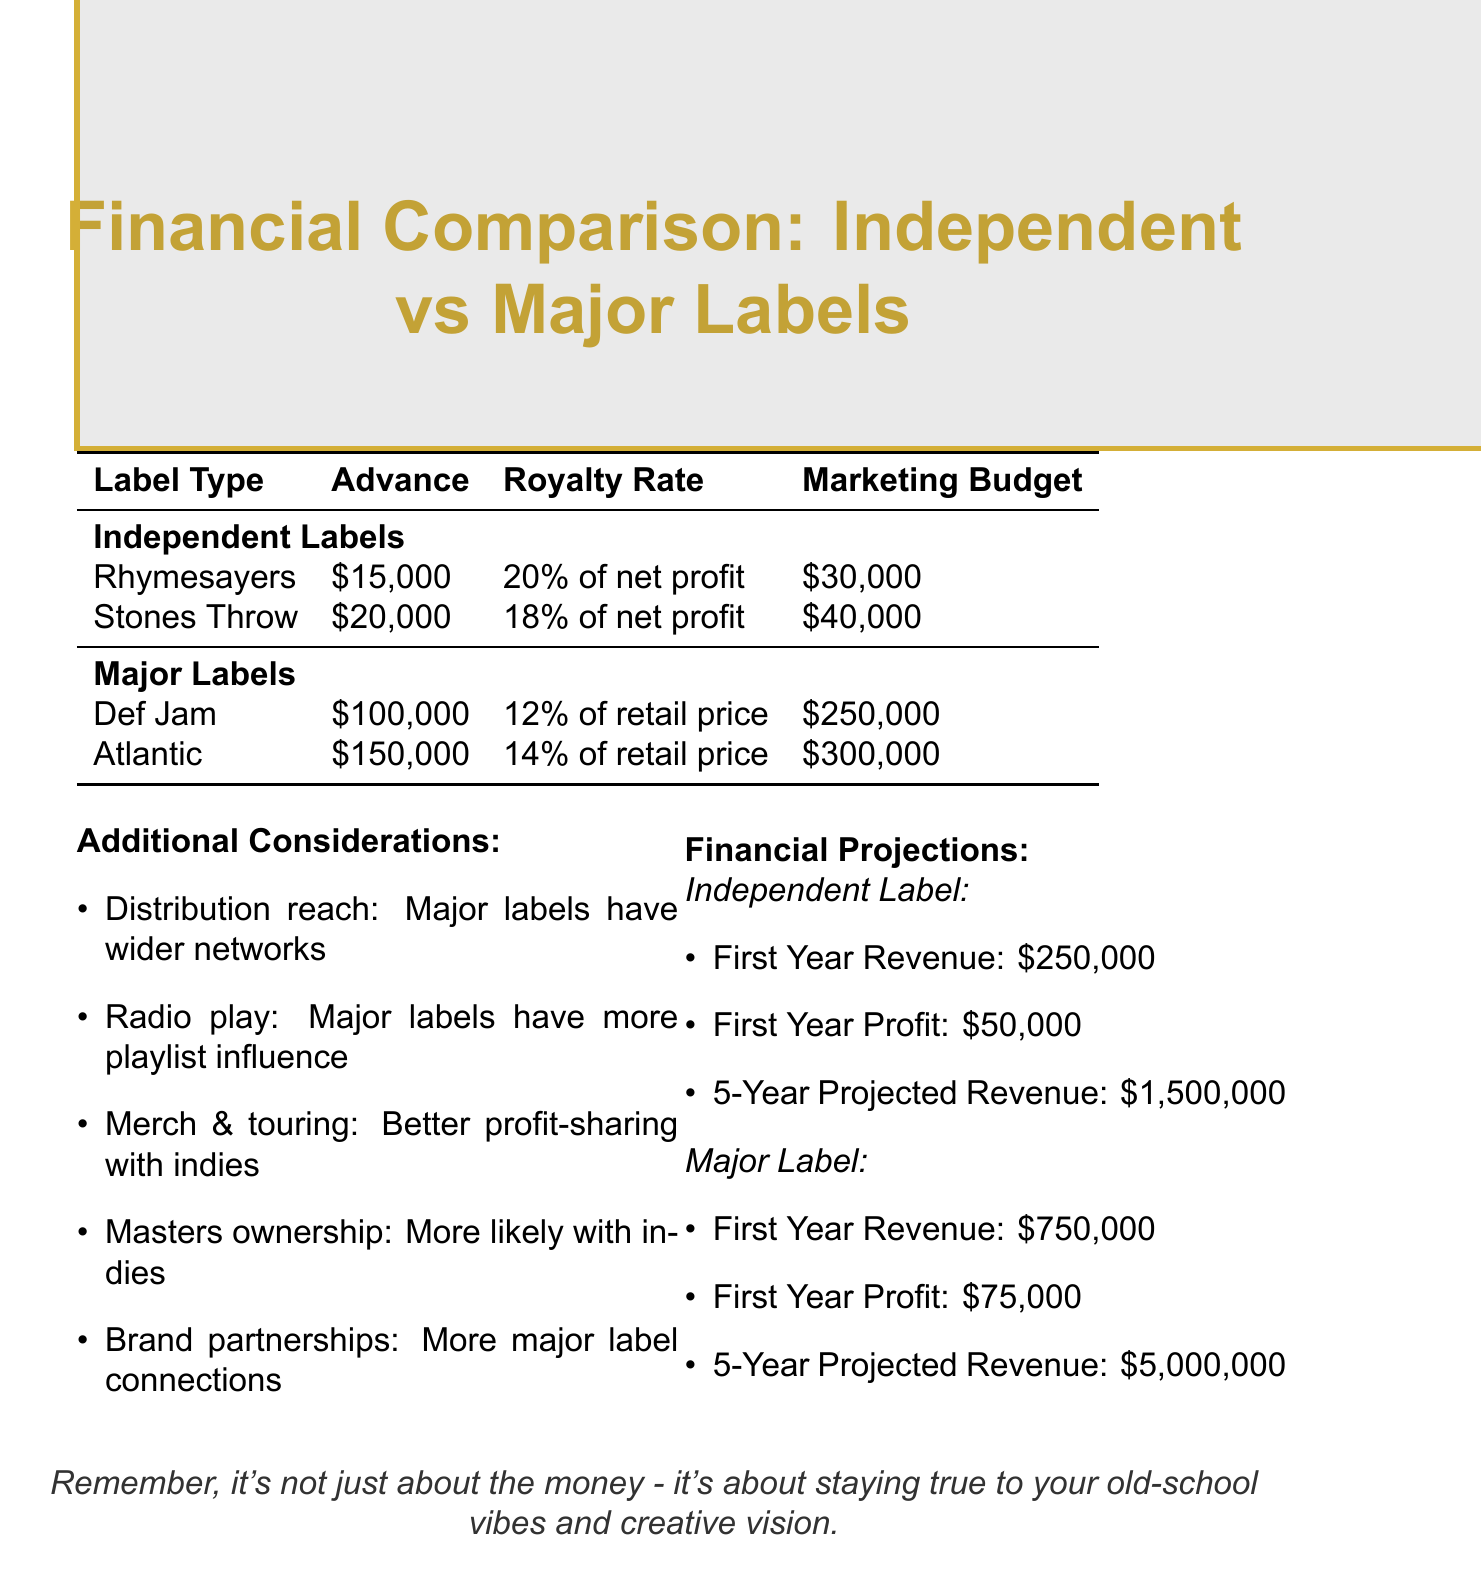What is the advance amount from Rhymesayers Entertainment? The advance amount is explicitly stated in the document under independent label offers, specifically for Rhymesayers Entertainment.
Answer: $15,000 What is the royalty rate offered by Atlantic Records? The royalty rate is listed in the section for major label contracts and is identified for Atlantic Records.
Answer: 14% of retail price What is the marketing budget for Stones Throw Records? The marketing budget is specified in the independent label offers section, detailing the amounts for each label.
Answer: $40,000 How many albums are required under the contract with Def Jam Recordings? The contract length is clearly stated in the document for each label and can be found beside Def Jam Recordings.
Answer: 4 albums Which label offers high creative control? The document outlines creative control levels for each label, and high is specifically associated with Rhymesayers Entertainment.
Answer: High What is the projected revenue for independent labels over five years? The financial projections section provides specific revenue estimates for both independent and major labels over a five-year period.
Answer: $1,500,000 Which type of label has wider distribution reach? The additional considerations section highlights distribution advantages of different label types, specifying major labels.
Answer: Major labels What is the first-year profit projection for major labels? The financial projections detail the first-year profit for each label type, which includes major labels under financial estimates.
Answer: $75,000 What is the marketing budget difference between Atlantic Records and Rhymesayers Entertainment? The marketing budgets for both labels are listed, and calculating their difference provides this specific value.
Answer: $270,000 